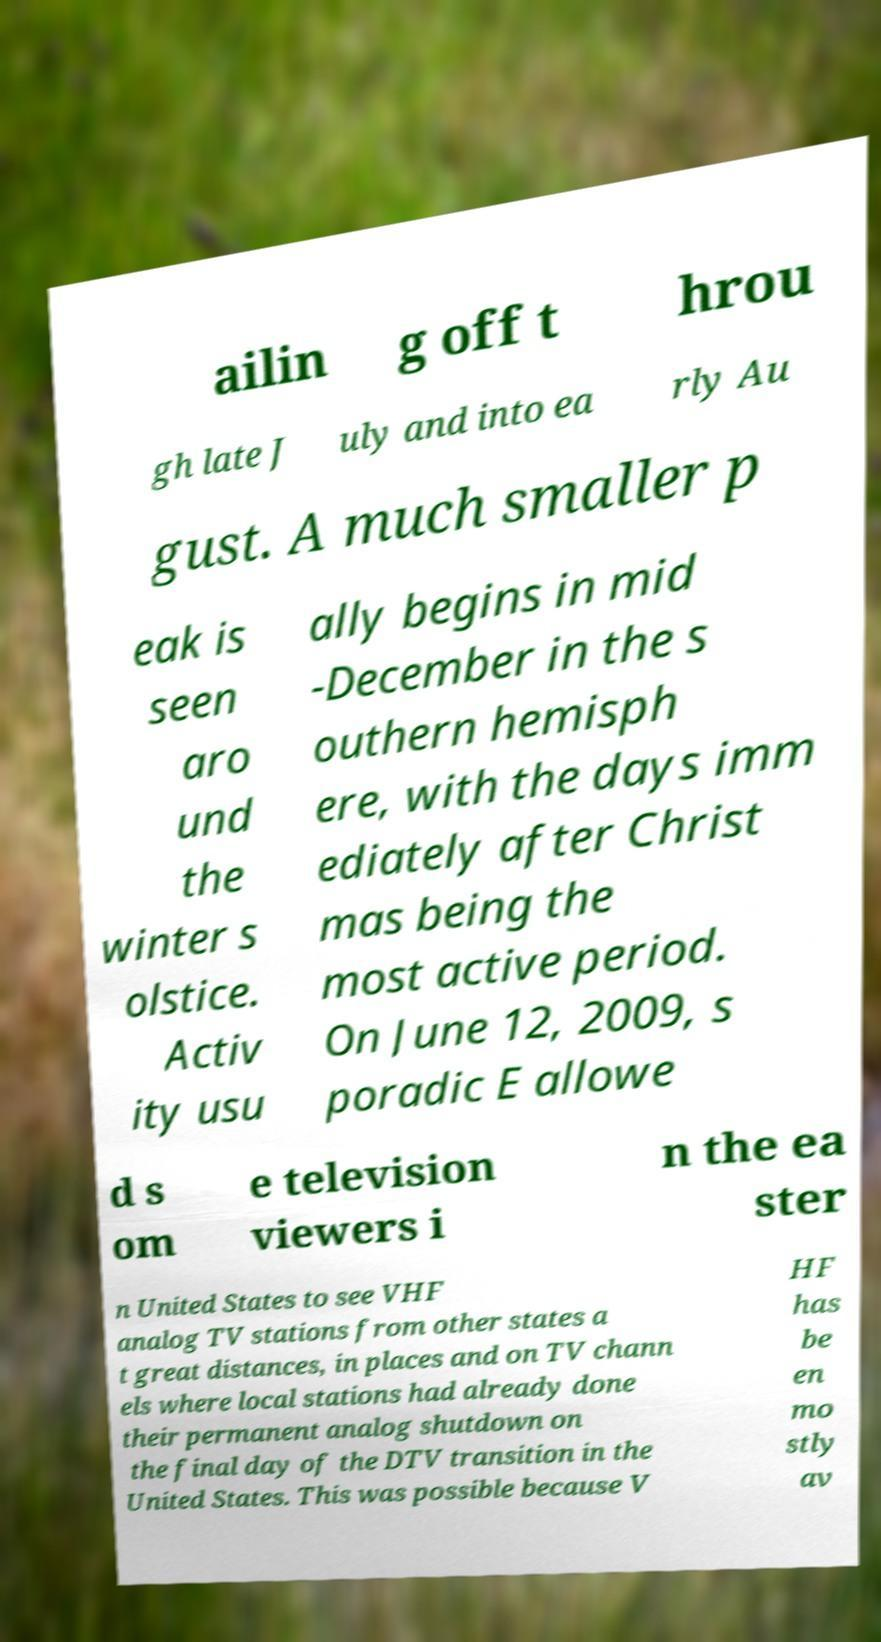Could you assist in decoding the text presented in this image and type it out clearly? ailin g off t hrou gh late J uly and into ea rly Au gust. A much smaller p eak is seen aro und the winter s olstice. Activ ity usu ally begins in mid -December in the s outhern hemisph ere, with the days imm ediately after Christ mas being the most active period. On June 12, 2009, s poradic E allowe d s om e television viewers i n the ea ster n United States to see VHF analog TV stations from other states a t great distances, in places and on TV chann els where local stations had already done their permanent analog shutdown on the final day of the DTV transition in the United States. This was possible because V HF has be en mo stly av 